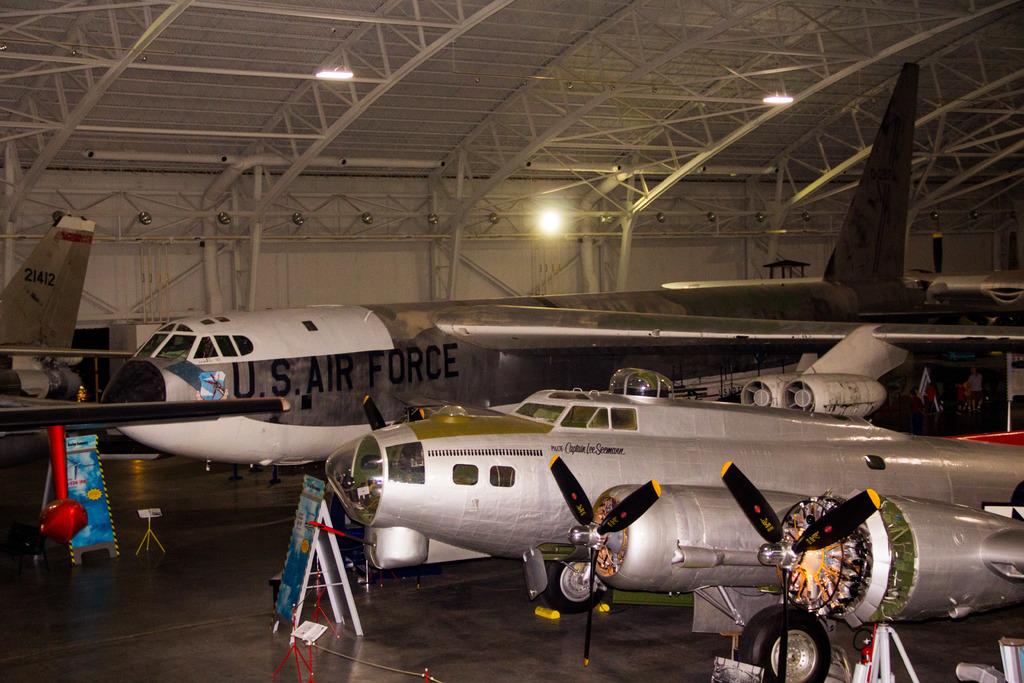Which branch of the us military does the plane belong to?
Make the answer very short. Air force. What is the number on the tail of the plane to the far left?
Your answer should be compact. 21412. 